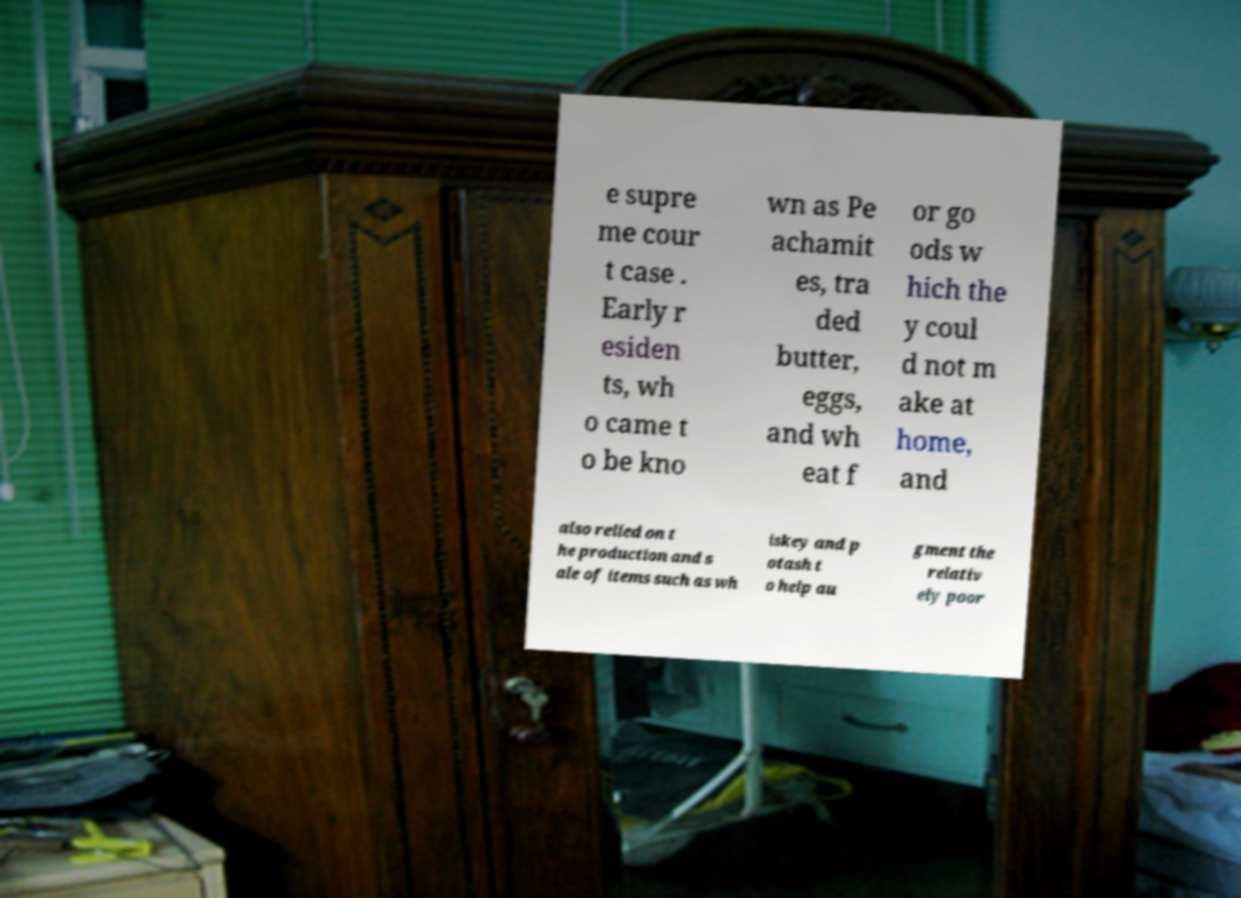Could you extract and type out the text from this image? e supre me cour t case . Early r esiden ts, wh o came t o be kno wn as Pe achamit es, tra ded butter, eggs, and wh eat f or go ods w hich the y coul d not m ake at home, and also relied on t he production and s ale of items such as wh iskey and p otash t o help au gment the relativ ely poor 